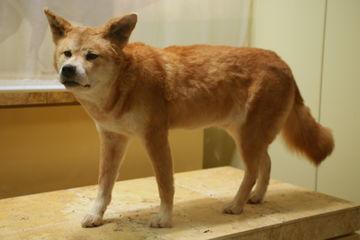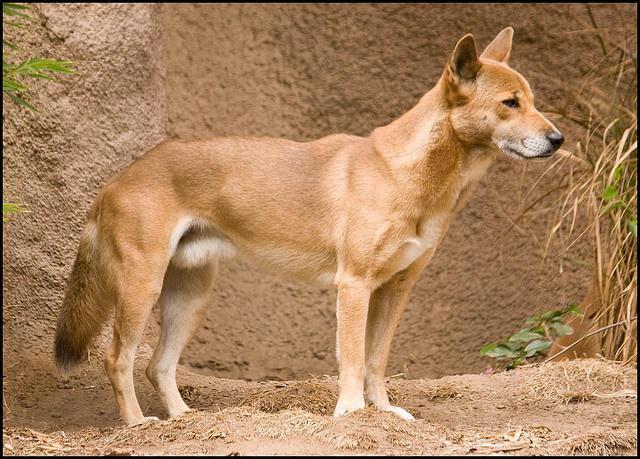The first image is the image on the left, the second image is the image on the right. Examine the images to the left and right. Is the description "Right image shows a canine looking directly into the camera." accurate? Answer yes or no. No. 